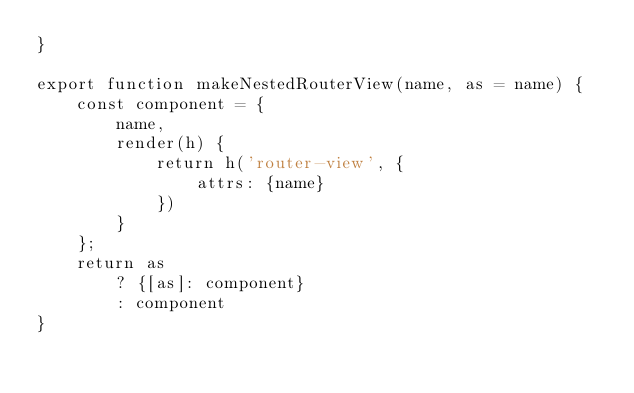<code> <loc_0><loc_0><loc_500><loc_500><_JavaScript_>}

export function makeNestedRouterView(name, as = name) {
    const component = {
        name,
        render(h) {
            return h('router-view', {
                attrs: {name}
            })
        }
    };
    return as
        ? {[as]: component}
        : component
}</code> 